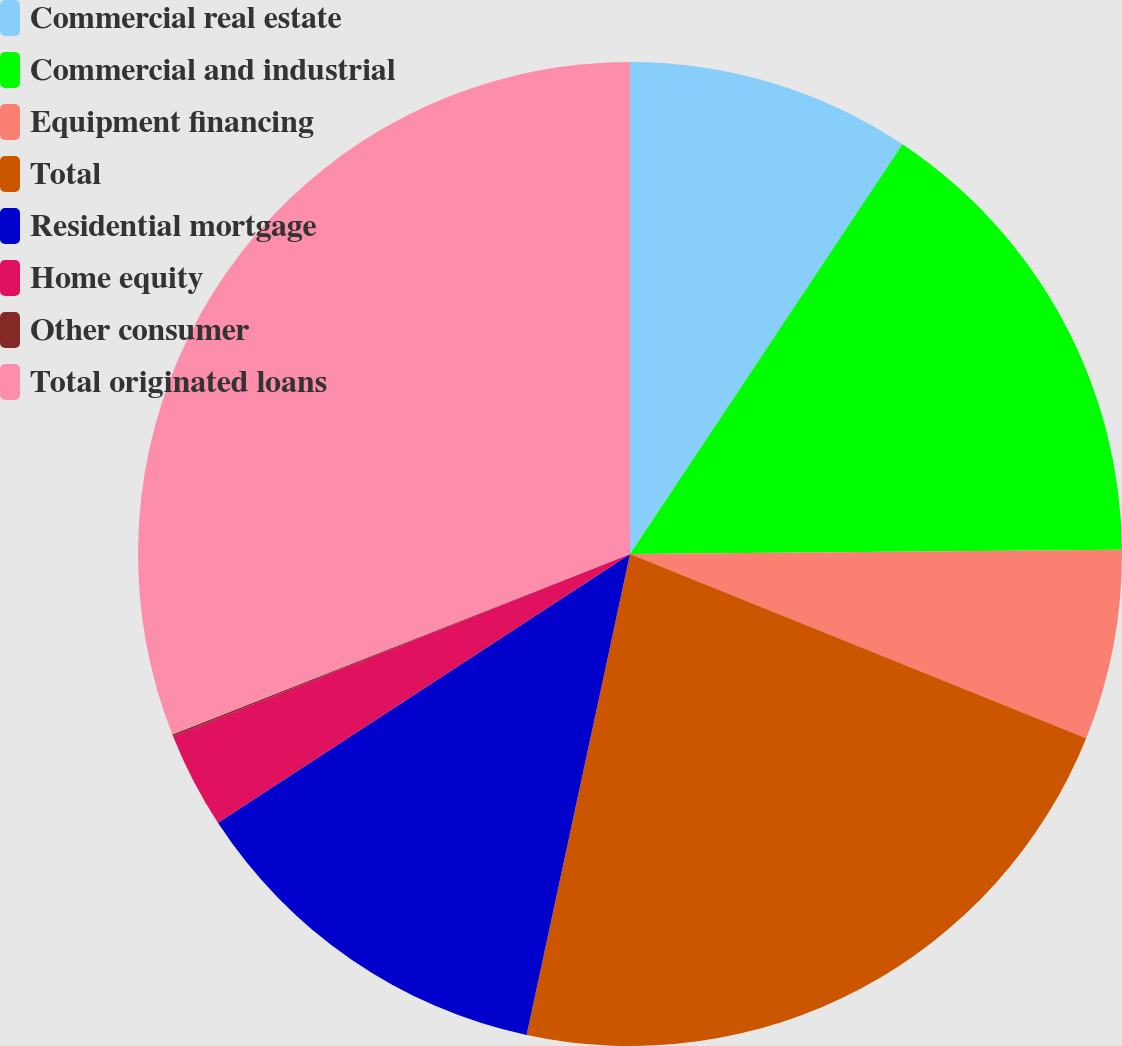Convert chart to OTSL. <chart><loc_0><loc_0><loc_500><loc_500><pie_chart><fcel>Commercial real estate<fcel>Commercial and industrial<fcel>Equipment financing<fcel>Total<fcel>Residential mortgage<fcel>Home equity<fcel>Other consumer<fcel>Total originated loans<nl><fcel>9.34%<fcel>15.52%<fcel>6.25%<fcel>22.26%<fcel>12.43%<fcel>3.16%<fcel>0.06%<fcel>30.98%<nl></chart> 